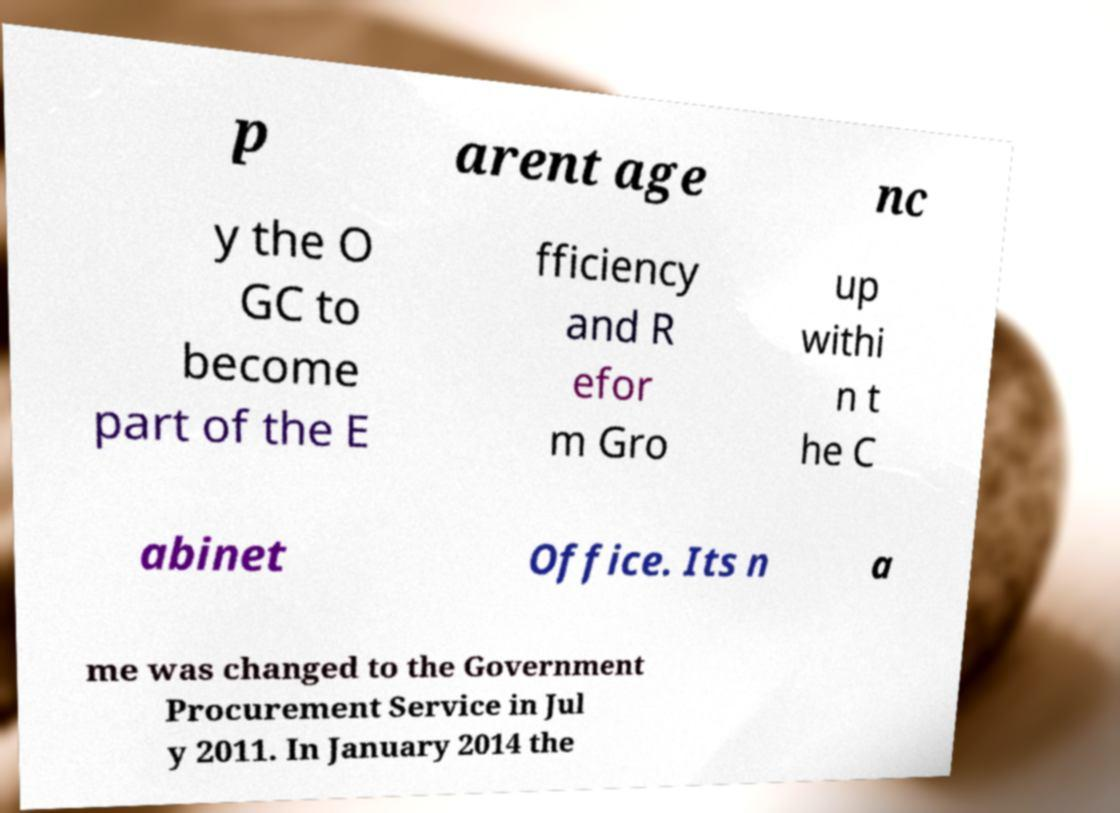Please identify and transcribe the text found in this image. p arent age nc y the O GC to become part of the E fficiency and R efor m Gro up withi n t he C abinet Office. Its n a me was changed to the Government Procurement Service in Jul y 2011. In January 2014 the 